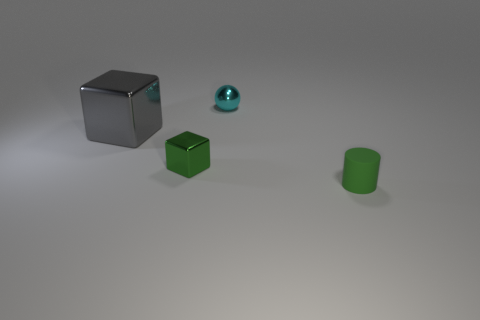Can you describe the lighting and shadows in the scene? The lighting in the scene comes from above, as indicated by the shadows directly underneath and slightly to the side of the objects. It's a soft light with gentle transitions from light to shadow, suggesting that the light source is diffused, perhaps in an indoor setting with ambient light or a softbox used in photography. 